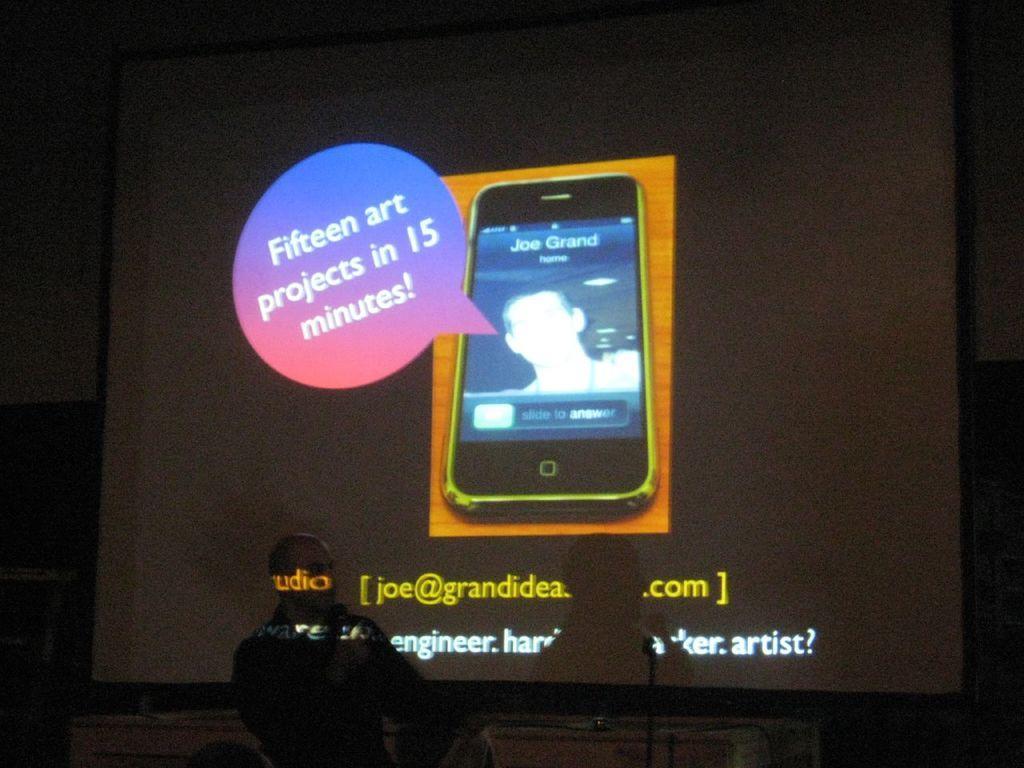Please provide a concise description of this image. In this picture I can see a person and also I can see a screen on which we can see a mobile with some text. 